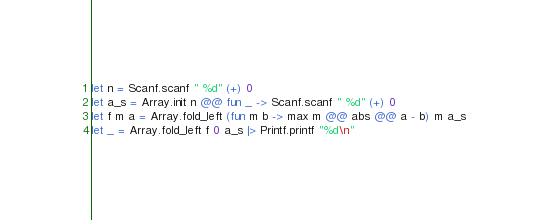<code> <loc_0><loc_0><loc_500><loc_500><_OCaml_>let n = Scanf.scanf " %d" (+) 0
let a_s = Array.init n @@ fun _ -> Scanf.scanf " %d" (+) 0
let f m a = Array.fold_left (fun m b -> max m @@ abs @@ a - b) m a_s
let _ = Array.fold_left f 0 a_s |> Printf.printf "%d\n"</code> 